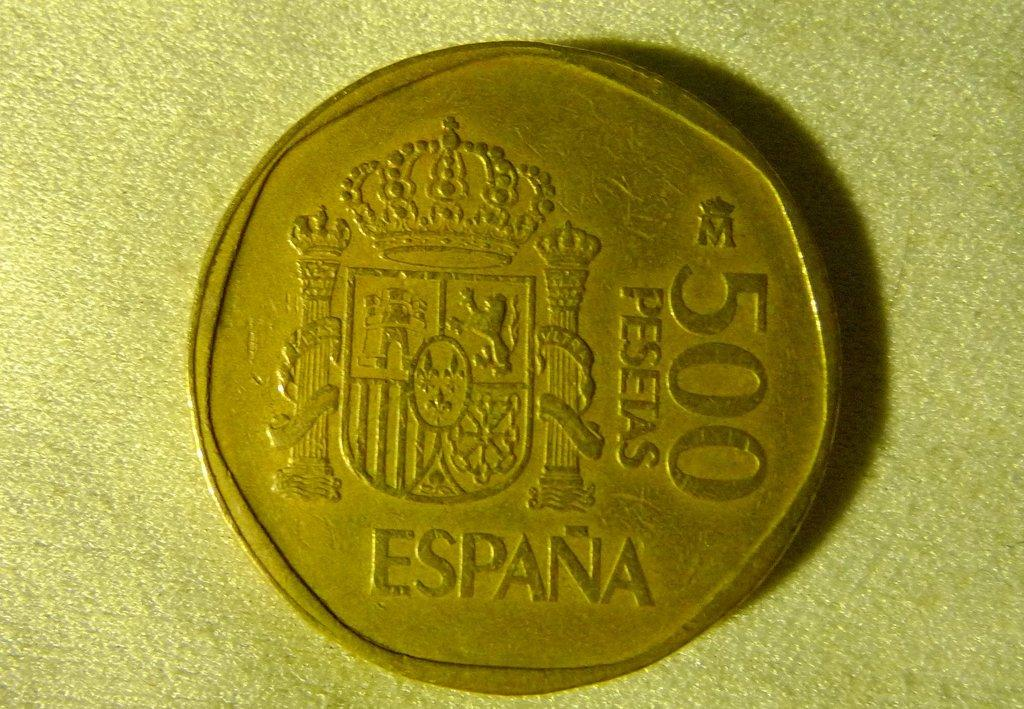<image>
Present a compact description of the photo's key features. A 500 pesetas coin from Espana is dull gold. 